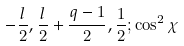Convert formula to latex. <formula><loc_0><loc_0><loc_500><loc_500>- { \frac { l } { 2 } } , { \frac { l } { 2 } } + { \frac { q - 1 } { 2 } } , { \frac { 1 } { 2 } } ; \cos ^ { 2 } \chi</formula> 